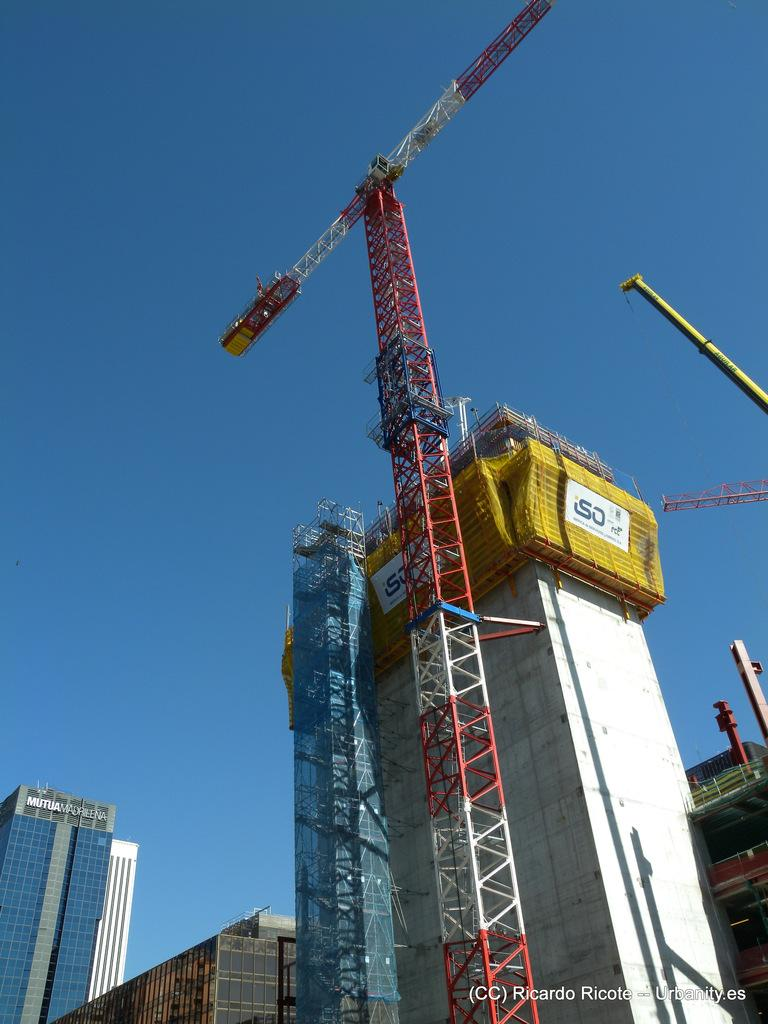What type of vehicle is present in the image? There is a mobile crane in the image. What else can be seen in the image besides the mobile crane? There are buildings and a sky visible in the background of the image. Can you describe the text on the right side of the image? There are white color words on the right side of the image. How many mice are sitting on the mobile crane in the image? There are no mice present in the image; it features a mobile crane, buildings, and a sky. What type of jelly is being used to construct the buildings in the image? There is no jelly present in the image; the buildings are made of conventional construction materials. 